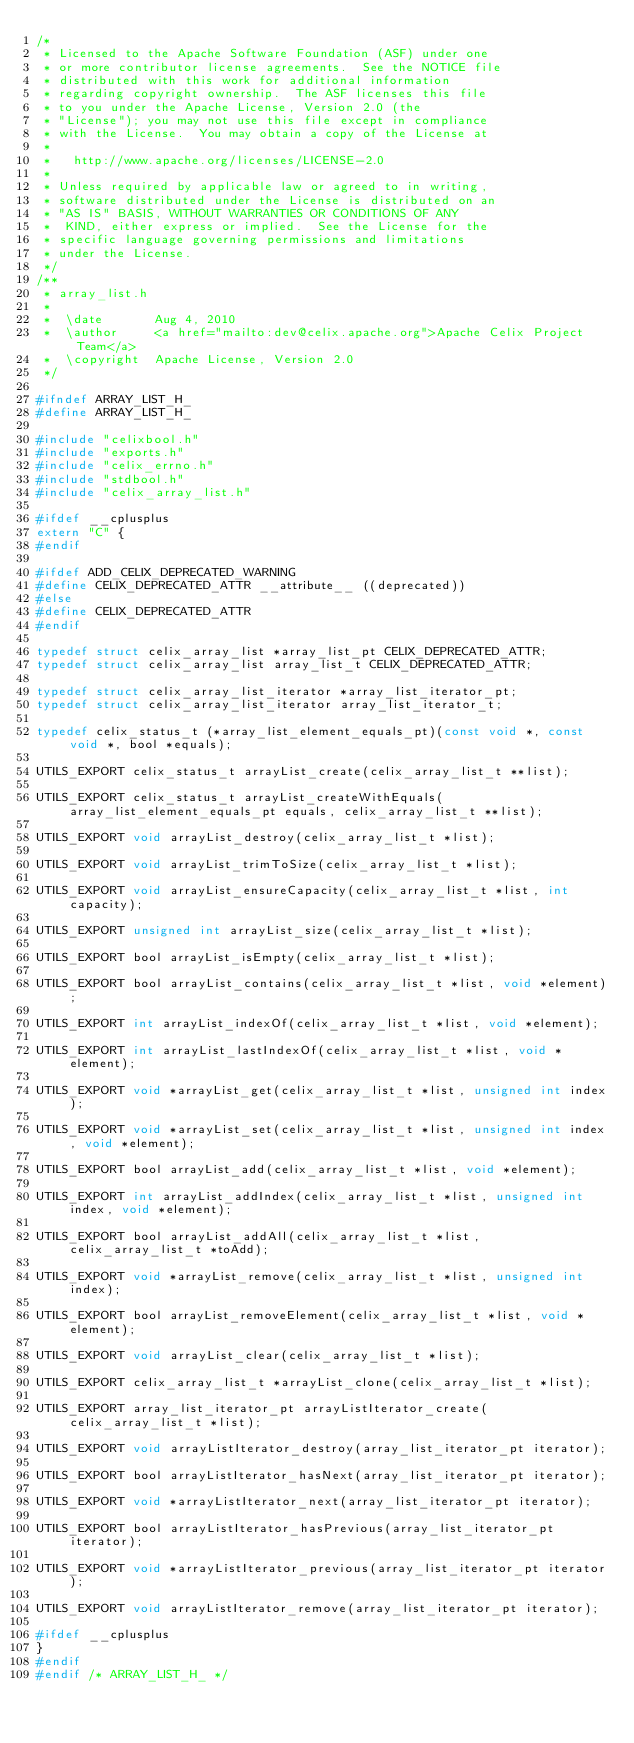Convert code to text. <code><loc_0><loc_0><loc_500><loc_500><_C_>/*
 * Licensed to the Apache Software Foundation (ASF) under one
 * or more contributor license agreements.  See the NOTICE file
 * distributed with this work for additional information
 * regarding copyright ownership.  The ASF licenses this file
 * to you under the Apache License, Version 2.0 (the
 * "License"); you may not use this file except in compliance
 * with the License.  You may obtain a copy of the License at
 *
 *   http://www.apache.org/licenses/LICENSE-2.0
 *
 * Unless required by applicable law or agreed to in writing,
 * software distributed under the License is distributed on an
 * "AS IS" BASIS, WITHOUT WARRANTIES OR CONDITIONS OF ANY
 *  KIND, either express or implied.  See the License for the
 * specific language governing permissions and limitations
 * under the License.
 */
/**
 * array_list.h
 *
 *  \date       Aug 4, 2010
 *  \author     <a href="mailto:dev@celix.apache.org">Apache Celix Project Team</a>
 *  \copyright  Apache License, Version 2.0
 */

#ifndef ARRAY_LIST_H_
#define ARRAY_LIST_H_

#include "celixbool.h"
#include "exports.h"
#include "celix_errno.h"
#include "stdbool.h"
#include "celix_array_list.h"

#ifdef __cplusplus
extern "C" {
#endif

#ifdef ADD_CELIX_DEPRECATED_WARNING
#define CELIX_DEPRECATED_ATTR __attribute__ ((deprecated))
#else
#define CELIX_DEPRECATED_ATTR
#endif

typedef struct celix_array_list *array_list_pt CELIX_DEPRECATED_ATTR;
typedef struct celix_array_list array_list_t CELIX_DEPRECATED_ATTR;

typedef struct celix_array_list_iterator *array_list_iterator_pt;
typedef struct celix_array_list_iterator array_list_iterator_t;

typedef celix_status_t (*array_list_element_equals_pt)(const void *, const void *, bool *equals);

UTILS_EXPORT celix_status_t arrayList_create(celix_array_list_t **list);

UTILS_EXPORT celix_status_t arrayList_createWithEquals(array_list_element_equals_pt equals, celix_array_list_t **list);

UTILS_EXPORT void arrayList_destroy(celix_array_list_t *list);

UTILS_EXPORT void arrayList_trimToSize(celix_array_list_t *list);

UTILS_EXPORT void arrayList_ensureCapacity(celix_array_list_t *list, int capacity);

UTILS_EXPORT unsigned int arrayList_size(celix_array_list_t *list);

UTILS_EXPORT bool arrayList_isEmpty(celix_array_list_t *list);

UTILS_EXPORT bool arrayList_contains(celix_array_list_t *list, void *element);

UTILS_EXPORT int arrayList_indexOf(celix_array_list_t *list, void *element);

UTILS_EXPORT int arrayList_lastIndexOf(celix_array_list_t *list, void *element);

UTILS_EXPORT void *arrayList_get(celix_array_list_t *list, unsigned int index);

UTILS_EXPORT void *arrayList_set(celix_array_list_t *list, unsigned int index, void *element);

UTILS_EXPORT bool arrayList_add(celix_array_list_t *list, void *element);

UTILS_EXPORT int arrayList_addIndex(celix_array_list_t *list, unsigned int index, void *element);

UTILS_EXPORT bool arrayList_addAll(celix_array_list_t *list, celix_array_list_t *toAdd);

UTILS_EXPORT void *arrayList_remove(celix_array_list_t *list, unsigned int index);

UTILS_EXPORT bool arrayList_removeElement(celix_array_list_t *list, void *element);

UTILS_EXPORT void arrayList_clear(celix_array_list_t *list);

UTILS_EXPORT celix_array_list_t *arrayList_clone(celix_array_list_t *list);

UTILS_EXPORT array_list_iterator_pt arrayListIterator_create(celix_array_list_t *list);

UTILS_EXPORT void arrayListIterator_destroy(array_list_iterator_pt iterator);

UTILS_EXPORT bool arrayListIterator_hasNext(array_list_iterator_pt iterator);

UTILS_EXPORT void *arrayListIterator_next(array_list_iterator_pt iterator);

UTILS_EXPORT bool arrayListIterator_hasPrevious(array_list_iterator_pt iterator);

UTILS_EXPORT void *arrayListIterator_previous(array_list_iterator_pt iterator);

UTILS_EXPORT void arrayListIterator_remove(array_list_iterator_pt iterator);

#ifdef __cplusplus
}
#endif
#endif /* ARRAY_LIST_H_ */
</code> 